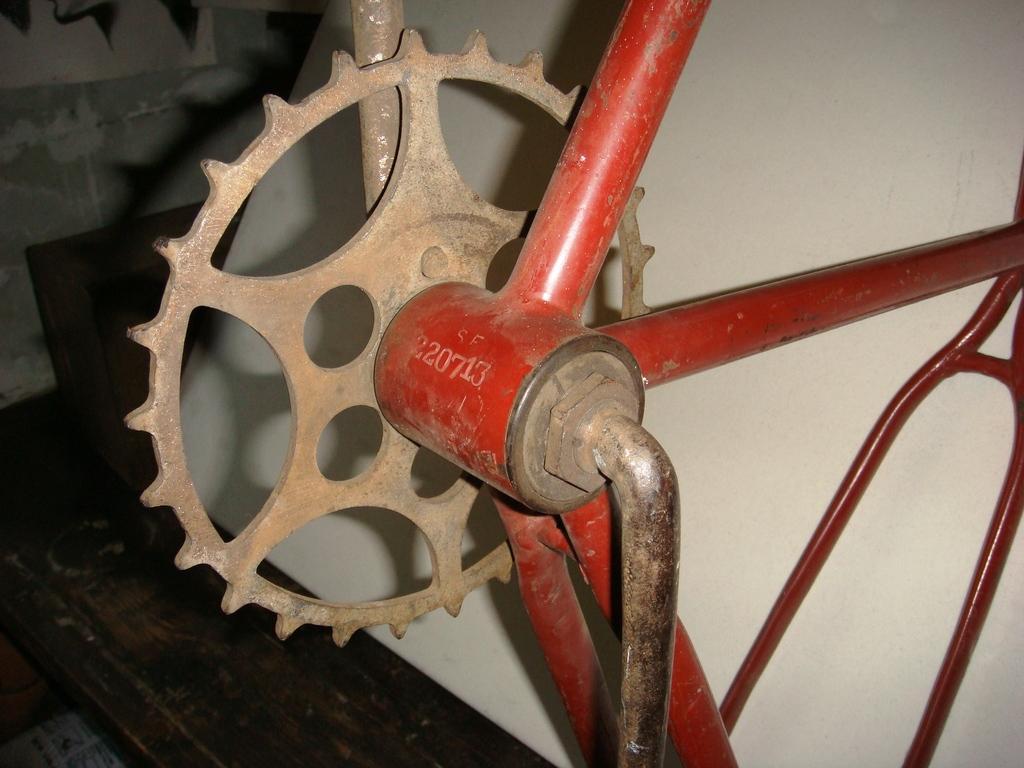Describe this image in one or two sentences. In this image I see an equipment over here which is of brown and red in color and I see something is written over here and I see the floor. In the background I see the wall. 